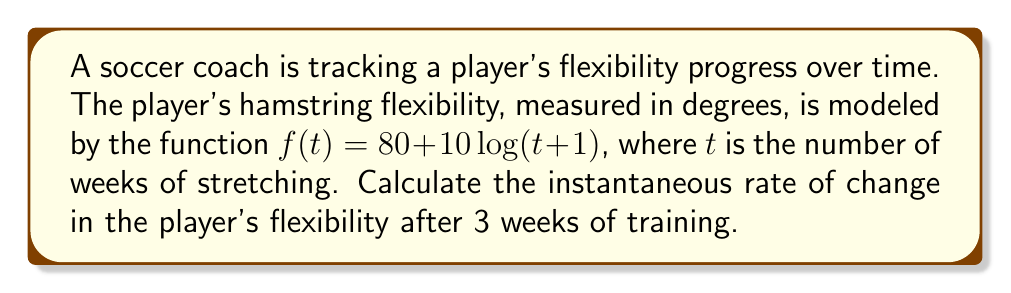Show me your answer to this math problem. To find the instantaneous rate of change in the player's flexibility after 3 weeks, we need to calculate the derivative of the function $f(t)$ and evaluate it at $t=3$.

1) First, let's find the derivative of $f(t)$:
   $f(t) = 80 + 10\log(t+1)$
   
   Using the chain rule:
   $$f'(t) = 10 \cdot \frac{d}{dt}[\log(t+1)] = 10 \cdot \frac{1}{t+1}$$

2) Now, we evaluate $f'(t)$ at $t=3$:
   $$f'(3) = 10 \cdot \frac{1}{3+1} = 10 \cdot \frac{1}{4} = 2.5$$

Therefore, the instantaneous rate of change in the player's flexibility after 3 weeks of training is 2.5 degrees per week.
Answer: 2.5 degrees per week 